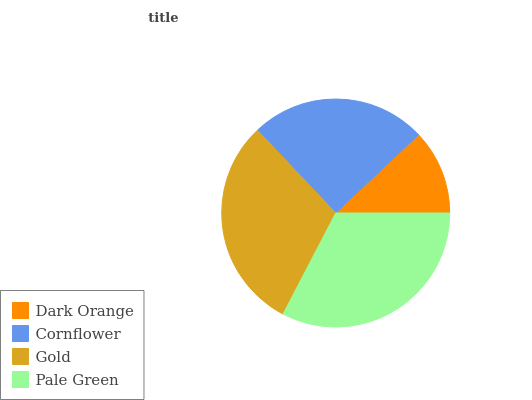Is Dark Orange the minimum?
Answer yes or no. Yes. Is Pale Green the maximum?
Answer yes or no. Yes. Is Cornflower the minimum?
Answer yes or no. No. Is Cornflower the maximum?
Answer yes or no. No. Is Cornflower greater than Dark Orange?
Answer yes or no. Yes. Is Dark Orange less than Cornflower?
Answer yes or no. Yes. Is Dark Orange greater than Cornflower?
Answer yes or no. No. Is Cornflower less than Dark Orange?
Answer yes or no. No. Is Gold the high median?
Answer yes or no. Yes. Is Cornflower the low median?
Answer yes or no. Yes. Is Dark Orange the high median?
Answer yes or no. No. Is Dark Orange the low median?
Answer yes or no. No. 